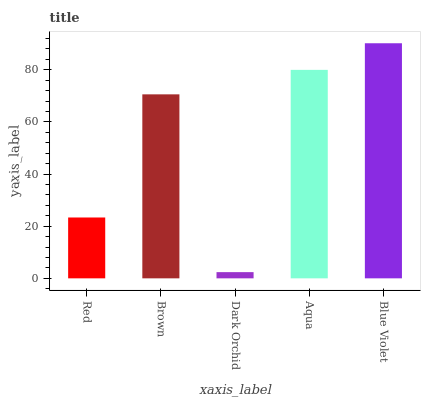Is Dark Orchid the minimum?
Answer yes or no. Yes. Is Blue Violet the maximum?
Answer yes or no. Yes. Is Brown the minimum?
Answer yes or no. No. Is Brown the maximum?
Answer yes or no. No. Is Brown greater than Red?
Answer yes or no. Yes. Is Red less than Brown?
Answer yes or no. Yes. Is Red greater than Brown?
Answer yes or no. No. Is Brown less than Red?
Answer yes or no. No. Is Brown the high median?
Answer yes or no. Yes. Is Brown the low median?
Answer yes or no. Yes. Is Aqua the high median?
Answer yes or no. No. Is Blue Violet the low median?
Answer yes or no. No. 